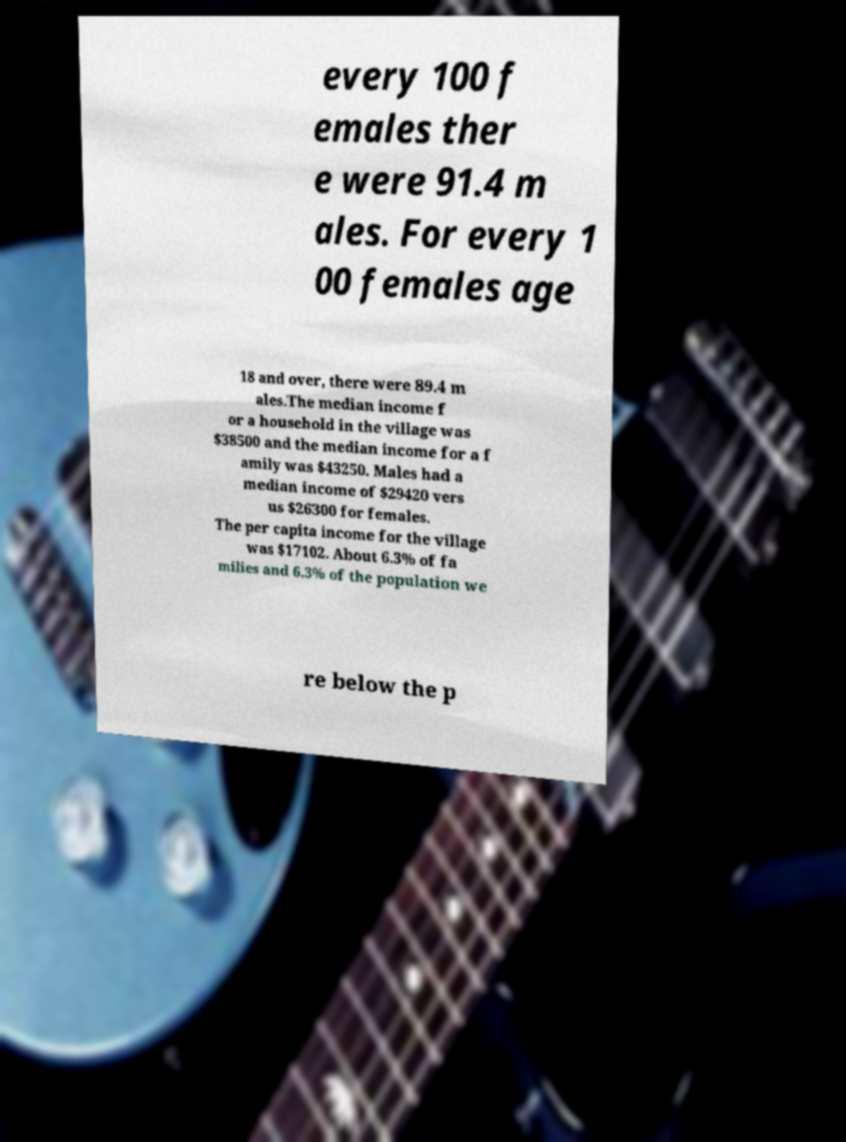Can you accurately transcribe the text from the provided image for me? every 100 f emales ther e were 91.4 m ales. For every 1 00 females age 18 and over, there were 89.4 m ales.The median income f or a household in the village was $38500 and the median income for a f amily was $43250. Males had a median income of $29420 vers us $26300 for females. The per capita income for the village was $17102. About 6.3% of fa milies and 6.3% of the population we re below the p 